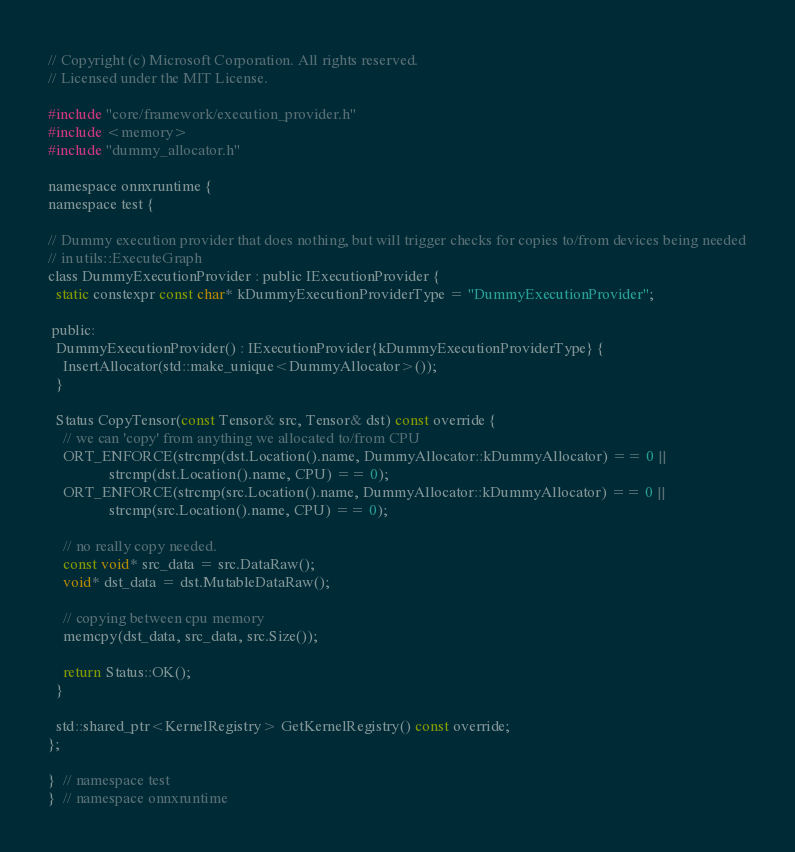<code> <loc_0><loc_0><loc_500><loc_500><_C_>// Copyright (c) Microsoft Corporation. All rights reserved.
// Licensed under the MIT License.

#include "core/framework/execution_provider.h"
#include <memory>
#include "dummy_allocator.h"

namespace onnxruntime {
namespace test {

// Dummy execution provider that does nothing, but will trigger checks for copies to/from devices being needed
// in utils::ExecuteGraph
class DummyExecutionProvider : public IExecutionProvider {
  static constexpr const char* kDummyExecutionProviderType = "DummyExecutionProvider";

 public:
  DummyExecutionProvider() : IExecutionProvider{kDummyExecutionProviderType} {
    InsertAllocator(std::make_unique<DummyAllocator>());
  }

  Status CopyTensor(const Tensor& src, Tensor& dst) const override {
    // we can 'copy' from anything we allocated to/from CPU
    ORT_ENFORCE(strcmp(dst.Location().name, DummyAllocator::kDummyAllocator) == 0 ||
                strcmp(dst.Location().name, CPU) == 0);
    ORT_ENFORCE(strcmp(src.Location().name, DummyAllocator::kDummyAllocator) == 0 ||
                strcmp(src.Location().name, CPU) == 0);

    // no really copy needed.
    const void* src_data = src.DataRaw();
    void* dst_data = dst.MutableDataRaw();

    // copying between cpu memory
    memcpy(dst_data, src_data, src.Size());

    return Status::OK();
  }

  std::shared_ptr<KernelRegistry> GetKernelRegistry() const override;
};

}  // namespace test
}  // namespace onnxruntime
</code> 